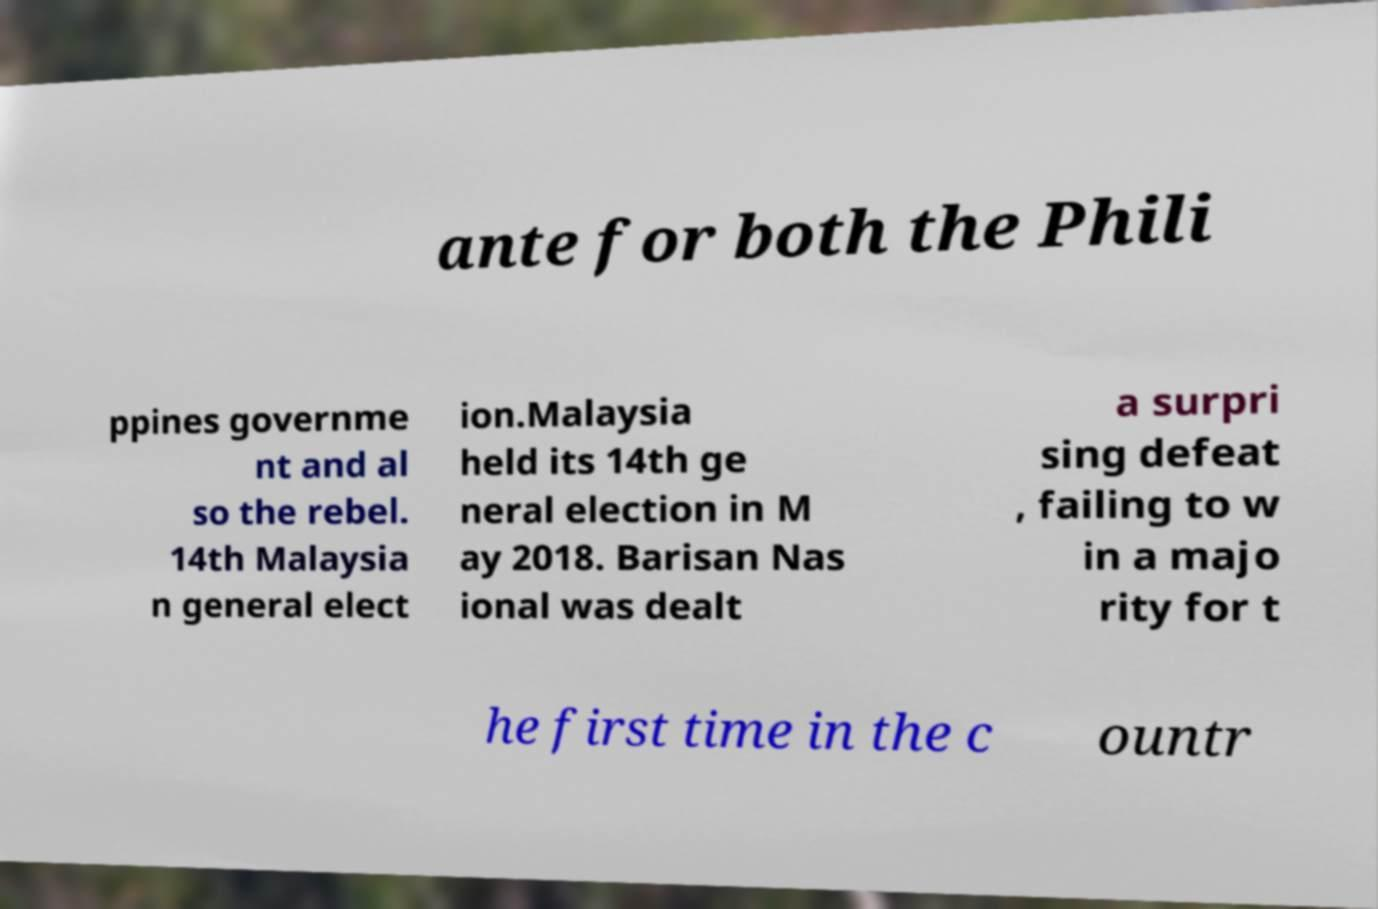What messages or text are displayed in this image? I need them in a readable, typed format. ante for both the Phili ppines governme nt and al so the rebel. 14th Malaysia n general elect ion.Malaysia held its 14th ge neral election in M ay 2018. Barisan Nas ional was dealt a surpri sing defeat , failing to w in a majo rity for t he first time in the c ountr 